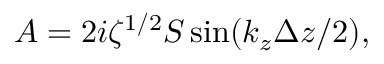<formula> <loc_0><loc_0><loc_500><loc_500>A = 2 i \zeta ^ { 1 / 2 } S \sin ( k _ { z } \Delta z / 2 ) ,</formula> 